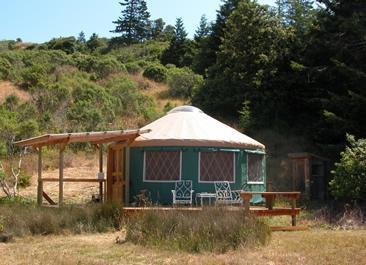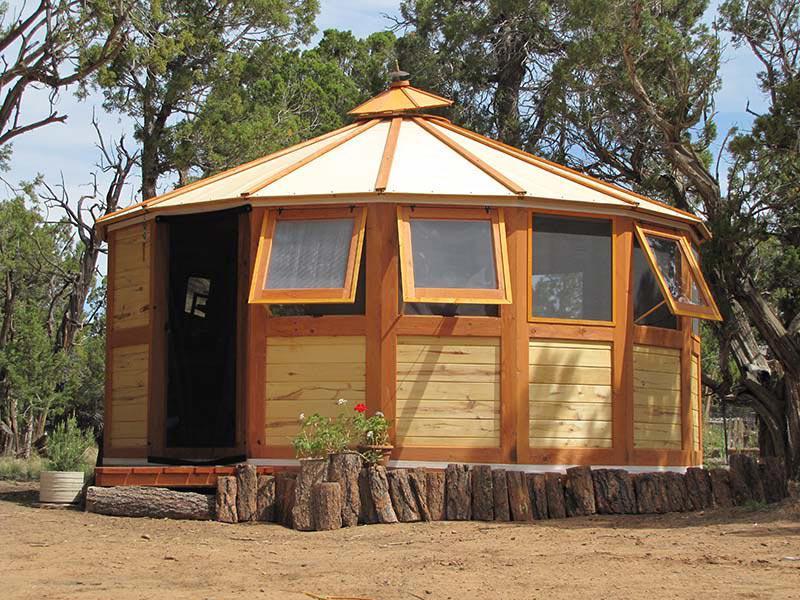The first image is the image on the left, the second image is the image on the right. For the images displayed, is the sentence "The building in the picture on the left is painted red." factually correct? Answer yes or no. No. 